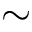Convert formula to latex. <formula><loc_0><loc_0><loc_500><loc_500>\sim</formula> 